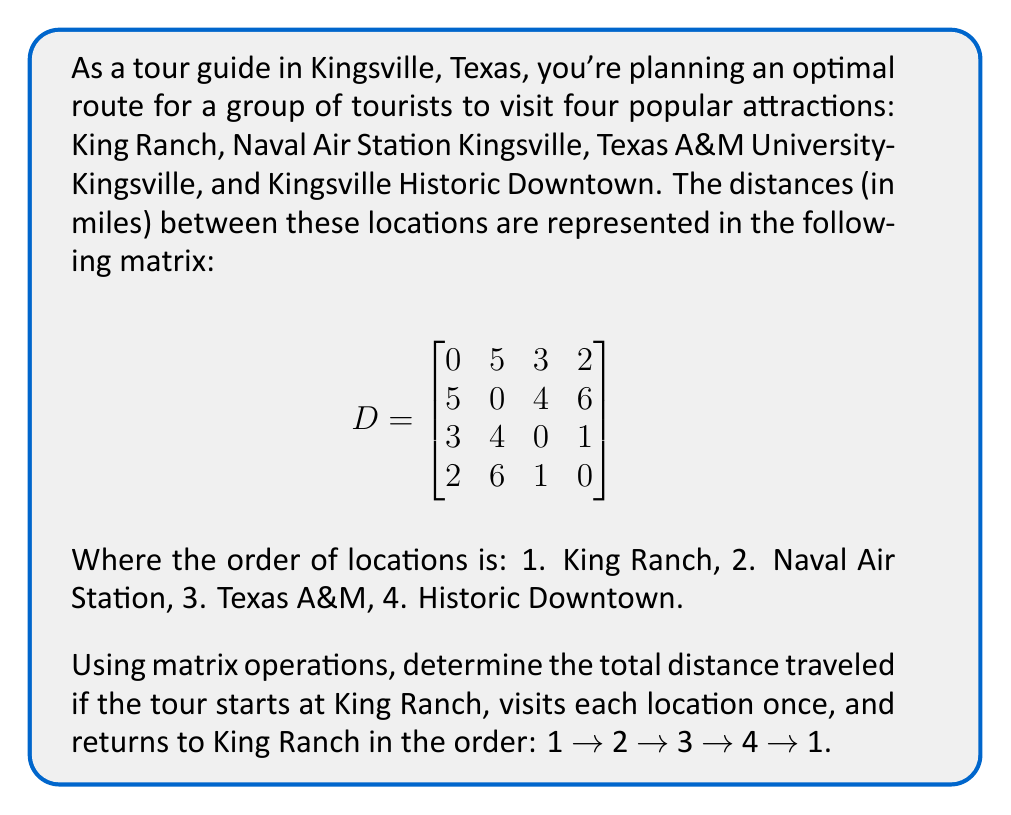Can you solve this math problem? To solve this problem, we'll use the given distance matrix and follow these steps:

1) The tour route is 1 → 2 → 3 → 4 → 1. We need to sum the distances between these consecutive locations.

2) From the matrix, we can identify these distances:
   - King Ranch to Naval Air Station (1 → 2): $D_{1,2} = 5$ miles
   - Naval Air Station to Texas A&M (2 → 3): $D_{2,3} = 4$ miles
   - Texas A&M to Historic Downtown (3 → 4): $D_{3,4} = 1$ mile
   - Historic Downtown back to King Ranch (4 → 1): $D_{4,1} = 2$ miles

3) To calculate the total distance, we sum these values:

   Total Distance = $D_{1,2} + D_{2,3} + D_{3,4} + D_{4,1}$
                  = $5 + 4 + 1 + 2$
                  = $12$ miles

Therefore, the total distance traveled for this tour route is 12 miles.
Answer: 12 miles 